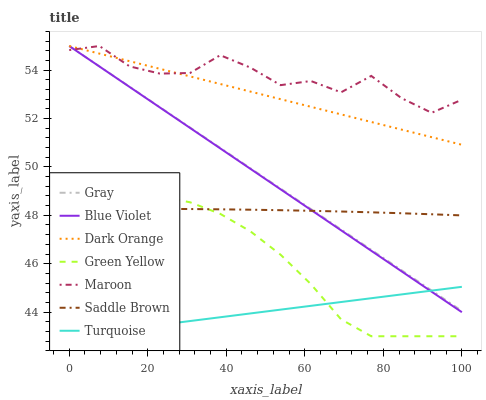Does Turquoise have the minimum area under the curve?
Answer yes or no. Yes. Does Maroon have the maximum area under the curve?
Answer yes or no. Yes. Does Dark Orange have the minimum area under the curve?
Answer yes or no. No. Does Dark Orange have the maximum area under the curve?
Answer yes or no. No. Is Dark Orange the smoothest?
Answer yes or no. Yes. Is Maroon the roughest?
Answer yes or no. Yes. Is Turquoise the smoothest?
Answer yes or no. No. Is Turquoise the roughest?
Answer yes or no. No. Does Turquoise have the lowest value?
Answer yes or no. Yes. Does Dark Orange have the lowest value?
Answer yes or no. No. Does Blue Violet have the highest value?
Answer yes or no. Yes. Does Turquoise have the highest value?
Answer yes or no. No. Is Saddle Brown less than Dark Orange?
Answer yes or no. Yes. Is Maroon greater than Turquoise?
Answer yes or no. Yes. Does Maroon intersect Blue Violet?
Answer yes or no. Yes. Is Maroon less than Blue Violet?
Answer yes or no. No. Is Maroon greater than Blue Violet?
Answer yes or no. No. Does Saddle Brown intersect Dark Orange?
Answer yes or no. No. 